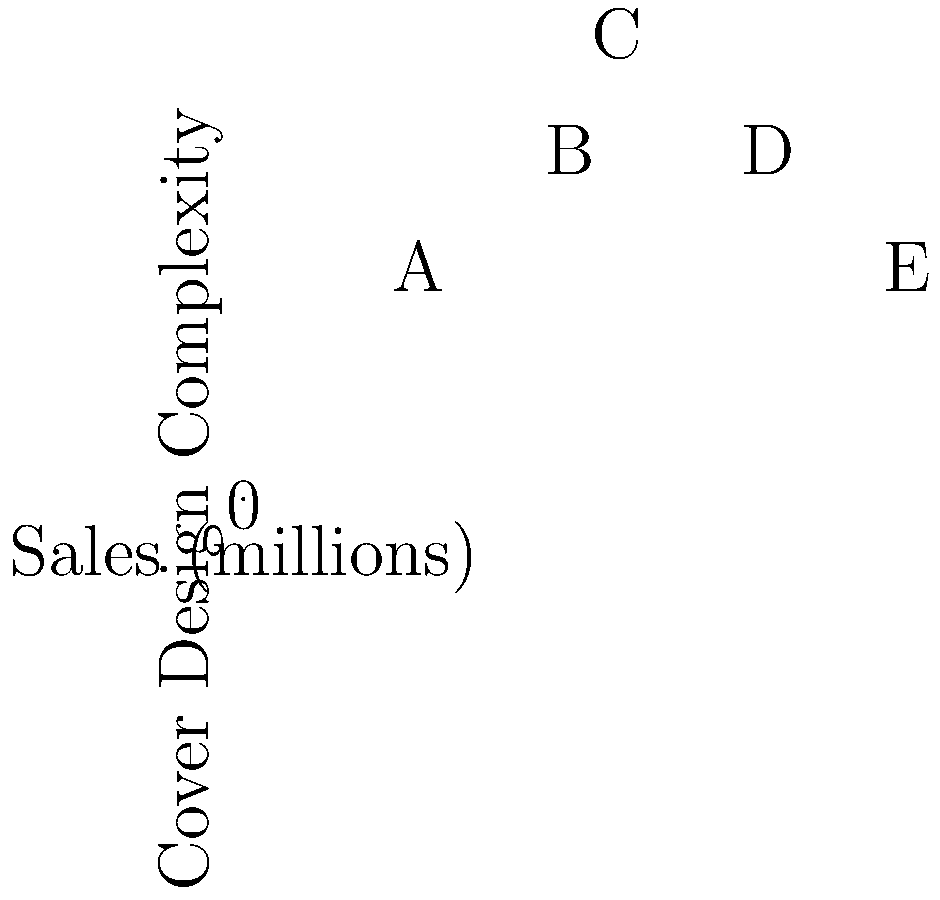Based on the scatter plot comparing book sales to cover design complexity for five bestselling novels (A-E), what trend can be inferred about the relationship between cover design complexity and sales potential? To answer this question, let's analyze the scatter plot step-by-step:

1. First, observe the x-axis (Sales in millions) and y-axis (Cover Design Complexity).

2. Identify the data points:
   A: (1.5, 2)
   B: (2.8, 3)
   C: (3.2, 4)
   D: (4.5, 3)
   E: (5.7, 2)

3. Look for a pattern in the data:
   - As we move from left to right (increasing sales), the complexity initially increases, then decreases.
   - The highest-selling book (E) has a low complexity score, similar to the lowest-selling book (A).
   - The middle-range sellers (B, C, D) have higher complexity scores.

4. Interpret the pattern:
   - There's no clear linear relationship between sales and cover complexity.
   - However, there appears to be an inverted U-shape or bell curve pattern.
   - Books with moderate complexity (3-4) seem to perform well in sales.
   - The top seller has a simpler design, suggesting that very complex designs might not necessarily lead to higher sales.

5. Consider the implications for bestsellers:
   - A moderately complex cover design might be optimal for attracting readers without overwhelming them.
   - Extremely simple or extremely complex designs might not be as effective in driving sales.

Given this analysis, we can infer that there's a non-linear relationship between cover design complexity and sales potential, with moderate complexity appearing to be most effective for bestsellers.
Answer: Moderate cover design complexity tends to correlate with higher sales potential. 